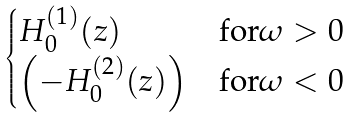<formula> <loc_0><loc_0><loc_500><loc_500>\begin{cases} H _ { 0 } ^ { ( 1 ) } ( z ) & \text {for} \omega > 0 \\ \left ( - H _ { 0 } ^ { ( 2 ) } ( z ) \right ) & \text {for} \omega < 0 \end{cases}</formula> 